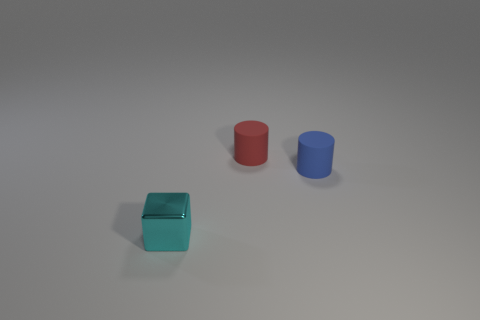Add 2 small red matte cylinders. How many objects exist? 5 Subtract all cylinders. How many objects are left? 1 Add 2 cylinders. How many cylinders are left? 4 Add 1 small cyan objects. How many small cyan objects exist? 2 Subtract 0 blue balls. How many objects are left? 3 Subtract all purple metal cubes. Subtract all small red cylinders. How many objects are left? 2 